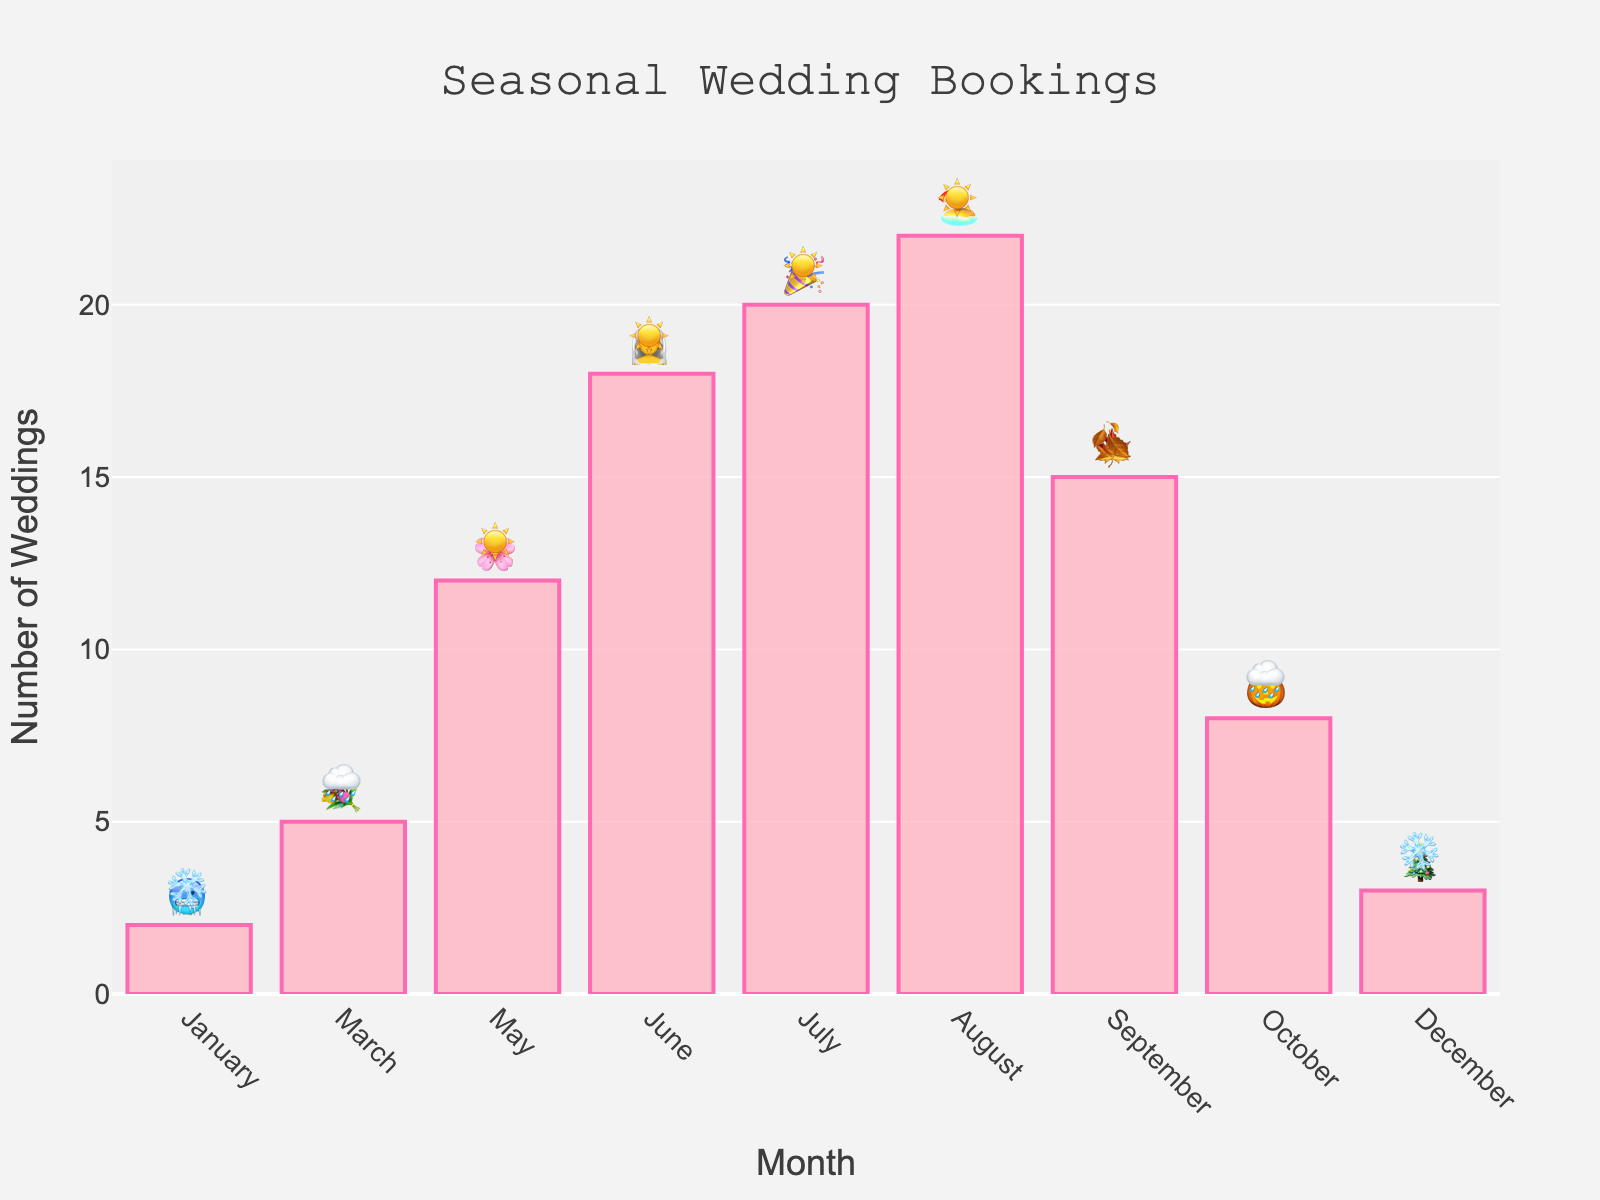Which month has the highest number of weddings? Looking at the height of the bars and noting the numbers, August has the highest with 22 weddings.
Answer: August How many weddings were booked in October? Check the bar corresponding to October and read the number of weddings, which is 8.
Answer: 8 What is the total number of weddings booked in both June and July? Add the weddings in June (18) and July (20): 18 + 20 = 38.
Answer: 38 Which months have weather emojis associated with the sun? Identify the sun emoji (☀️) in the figure and note the associated months: May, June, July, August.
Answer: May, June, July, August How does the number of weddings in December compare with January? Compare the bar heights or numbers directly: December has 3 weddings, while January has 2; December is higher by 1 wedding.
Answer: December is higher In which seasons do the highest number of weddings occur? Observe the bars for the seasons, noting the height: Summer months (June, July, August) have the highest count, specifically July and August.
Answer: Summer Which month shows the least number of weddings, and what is the associated weather? Identify the smallest bar height, which is January with 2 weddings, associated with weather emoji ❄️.
Answer: January, ❄️ What is the average number of weddings per month? Sum all the weddings and divide by the number of months. Total weddings: 2 + 5 + 12 + 18 + 20 + 22 + 15 + 8 + 3 = 105. There are 9 months listed, so 105 / 9 ≈ 11.67.
Answer: 11.67 Which months feature both a seasonal celebration and weather surprise emoji? Check the columns for both the celebration and weather emojis: March (💐, 🌧️), May (🌸, ☀️), June (👰, ☀️), July (🎉, ☀️), August (🏖️, ☀️), September (🍁, 🍂), October (🎃, 🌧️), December (🎄, ❄️).
Answer: March, May, June, July, August, September, October, December Is there a greater tendency for weddings in months with better weather represented by the emoji? Compare the bars with the sun emoji (☀️) against those with snow or rain: May, June, July, August (☀️) have higher weddings compared to months with ❄️ or 🌧️.
Answer: Yes 